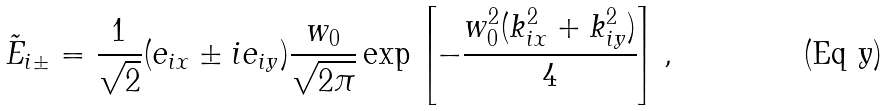Convert formula to latex. <formula><loc_0><loc_0><loc_500><loc_500>\tilde { E } _ { i \pm } = \frac { 1 } { \sqrt { 2 } } ( e _ { i x } \pm i e _ { i y } ) \frac { w _ { 0 } } { \sqrt { 2 \pi } } \exp \left [ - \frac { w _ { 0 } ^ { 2 } ( k _ { i x } ^ { 2 } + k _ { i y } ^ { 2 } ) } { 4 } \right ] ,</formula> 